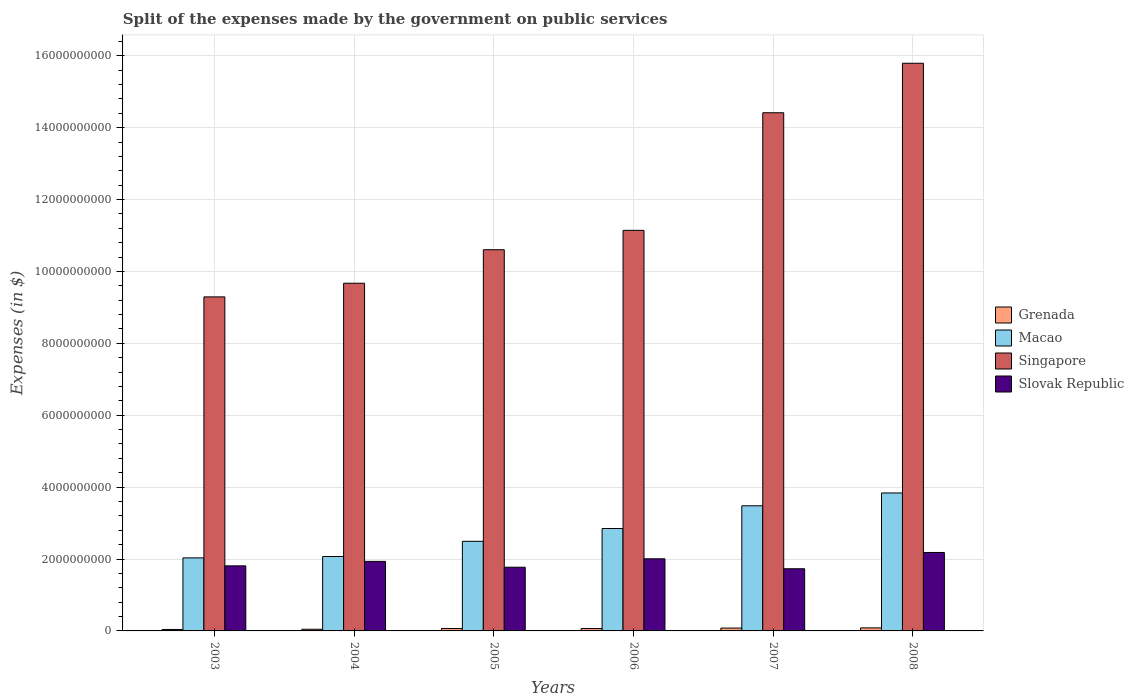How many bars are there on the 4th tick from the right?
Offer a terse response. 4. In how many cases, is the number of bars for a given year not equal to the number of legend labels?
Give a very brief answer. 0. What is the expenses made by the government on public services in Grenada in 2007?
Provide a succinct answer. 7.91e+07. Across all years, what is the maximum expenses made by the government on public services in Singapore?
Provide a short and direct response. 1.58e+1. Across all years, what is the minimum expenses made by the government on public services in Grenada?
Ensure brevity in your answer.  4.05e+07. What is the total expenses made by the government on public services in Slovak Republic in the graph?
Provide a succinct answer. 1.14e+1. What is the difference between the expenses made by the government on public services in Grenada in 2003 and that in 2005?
Provide a succinct answer. -2.74e+07. What is the difference between the expenses made by the government on public services in Grenada in 2006 and the expenses made by the government on public services in Macao in 2004?
Your answer should be compact. -2.00e+09. What is the average expenses made by the government on public services in Slovak Republic per year?
Give a very brief answer. 1.91e+09. In the year 2003, what is the difference between the expenses made by the government on public services in Singapore and expenses made by the government on public services in Grenada?
Provide a short and direct response. 9.25e+09. In how many years, is the expenses made by the government on public services in Slovak Republic greater than 2800000000 $?
Provide a succinct answer. 0. What is the ratio of the expenses made by the government on public services in Slovak Republic in 2005 to that in 2006?
Give a very brief answer. 0.88. Is the difference between the expenses made by the government on public services in Singapore in 2005 and 2007 greater than the difference between the expenses made by the government on public services in Grenada in 2005 and 2007?
Ensure brevity in your answer.  No. What is the difference between the highest and the second highest expenses made by the government on public services in Singapore?
Keep it short and to the point. 1.38e+09. What is the difference between the highest and the lowest expenses made by the government on public services in Grenada?
Give a very brief answer. 4.42e+07. In how many years, is the expenses made by the government on public services in Slovak Republic greater than the average expenses made by the government on public services in Slovak Republic taken over all years?
Your answer should be very brief. 3. Is the sum of the expenses made by the government on public services in Grenada in 2004 and 2007 greater than the maximum expenses made by the government on public services in Slovak Republic across all years?
Keep it short and to the point. No. Is it the case that in every year, the sum of the expenses made by the government on public services in Slovak Republic and expenses made by the government on public services in Macao is greater than the sum of expenses made by the government on public services in Singapore and expenses made by the government on public services in Grenada?
Give a very brief answer. Yes. What does the 3rd bar from the left in 2003 represents?
Provide a short and direct response. Singapore. What does the 4th bar from the right in 2007 represents?
Provide a succinct answer. Grenada. Is it the case that in every year, the sum of the expenses made by the government on public services in Singapore and expenses made by the government on public services in Grenada is greater than the expenses made by the government on public services in Slovak Republic?
Offer a terse response. Yes. How many years are there in the graph?
Your answer should be compact. 6. Does the graph contain grids?
Provide a short and direct response. Yes. How many legend labels are there?
Your answer should be very brief. 4. What is the title of the graph?
Provide a short and direct response. Split of the expenses made by the government on public services. What is the label or title of the Y-axis?
Your response must be concise. Expenses (in $). What is the Expenses (in $) in Grenada in 2003?
Provide a succinct answer. 4.05e+07. What is the Expenses (in $) of Macao in 2003?
Ensure brevity in your answer.  2.03e+09. What is the Expenses (in $) of Singapore in 2003?
Provide a succinct answer. 9.29e+09. What is the Expenses (in $) in Slovak Republic in 2003?
Make the answer very short. 1.81e+09. What is the Expenses (in $) in Grenada in 2004?
Make the answer very short. 4.61e+07. What is the Expenses (in $) in Macao in 2004?
Ensure brevity in your answer.  2.07e+09. What is the Expenses (in $) in Singapore in 2004?
Provide a succinct answer. 9.67e+09. What is the Expenses (in $) in Slovak Republic in 2004?
Make the answer very short. 1.93e+09. What is the Expenses (in $) in Grenada in 2005?
Provide a short and direct response. 6.79e+07. What is the Expenses (in $) of Macao in 2005?
Your response must be concise. 2.49e+09. What is the Expenses (in $) of Singapore in 2005?
Your response must be concise. 1.06e+1. What is the Expenses (in $) in Slovak Republic in 2005?
Offer a terse response. 1.77e+09. What is the Expenses (in $) of Grenada in 2006?
Ensure brevity in your answer.  6.61e+07. What is the Expenses (in $) in Macao in 2006?
Provide a short and direct response. 2.85e+09. What is the Expenses (in $) in Singapore in 2006?
Ensure brevity in your answer.  1.11e+1. What is the Expenses (in $) in Slovak Republic in 2006?
Your answer should be very brief. 2.01e+09. What is the Expenses (in $) in Grenada in 2007?
Offer a terse response. 7.91e+07. What is the Expenses (in $) in Macao in 2007?
Provide a succinct answer. 3.48e+09. What is the Expenses (in $) in Singapore in 2007?
Ensure brevity in your answer.  1.44e+1. What is the Expenses (in $) of Slovak Republic in 2007?
Provide a short and direct response. 1.73e+09. What is the Expenses (in $) of Grenada in 2008?
Your response must be concise. 8.47e+07. What is the Expenses (in $) in Macao in 2008?
Your answer should be compact. 3.84e+09. What is the Expenses (in $) in Singapore in 2008?
Give a very brief answer. 1.58e+1. What is the Expenses (in $) in Slovak Republic in 2008?
Provide a succinct answer. 2.18e+09. Across all years, what is the maximum Expenses (in $) of Grenada?
Offer a terse response. 8.47e+07. Across all years, what is the maximum Expenses (in $) of Macao?
Offer a terse response. 3.84e+09. Across all years, what is the maximum Expenses (in $) in Singapore?
Provide a succinct answer. 1.58e+1. Across all years, what is the maximum Expenses (in $) of Slovak Republic?
Offer a terse response. 2.18e+09. Across all years, what is the minimum Expenses (in $) in Grenada?
Keep it short and to the point. 4.05e+07. Across all years, what is the minimum Expenses (in $) in Macao?
Offer a very short reply. 2.03e+09. Across all years, what is the minimum Expenses (in $) in Singapore?
Your answer should be compact. 9.29e+09. Across all years, what is the minimum Expenses (in $) of Slovak Republic?
Ensure brevity in your answer.  1.73e+09. What is the total Expenses (in $) of Grenada in the graph?
Give a very brief answer. 3.84e+08. What is the total Expenses (in $) of Macao in the graph?
Give a very brief answer. 1.68e+1. What is the total Expenses (in $) of Singapore in the graph?
Ensure brevity in your answer.  7.09e+1. What is the total Expenses (in $) of Slovak Republic in the graph?
Your answer should be compact. 1.14e+1. What is the difference between the Expenses (in $) in Grenada in 2003 and that in 2004?
Give a very brief answer. -5.60e+06. What is the difference between the Expenses (in $) of Macao in 2003 and that in 2004?
Your answer should be compact. -3.86e+07. What is the difference between the Expenses (in $) of Singapore in 2003 and that in 2004?
Make the answer very short. -3.80e+08. What is the difference between the Expenses (in $) of Slovak Republic in 2003 and that in 2004?
Ensure brevity in your answer.  -1.24e+08. What is the difference between the Expenses (in $) in Grenada in 2003 and that in 2005?
Your answer should be compact. -2.74e+07. What is the difference between the Expenses (in $) of Macao in 2003 and that in 2005?
Provide a succinct answer. -4.61e+08. What is the difference between the Expenses (in $) in Singapore in 2003 and that in 2005?
Keep it short and to the point. -1.31e+09. What is the difference between the Expenses (in $) in Slovak Republic in 2003 and that in 2005?
Your answer should be compact. 3.79e+07. What is the difference between the Expenses (in $) of Grenada in 2003 and that in 2006?
Ensure brevity in your answer.  -2.56e+07. What is the difference between the Expenses (in $) of Macao in 2003 and that in 2006?
Make the answer very short. -8.17e+08. What is the difference between the Expenses (in $) of Singapore in 2003 and that in 2006?
Provide a succinct answer. -1.85e+09. What is the difference between the Expenses (in $) of Slovak Republic in 2003 and that in 2006?
Provide a succinct answer. -1.96e+08. What is the difference between the Expenses (in $) of Grenada in 2003 and that in 2007?
Offer a terse response. -3.86e+07. What is the difference between the Expenses (in $) in Macao in 2003 and that in 2007?
Make the answer very short. -1.45e+09. What is the difference between the Expenses (in $) of Singapore in 2003 and that in 2007?
Give a very brief answer. -5.12e+09. What is the difference between the Expenses (in $) in Slovak Republic in 2003 and that in 2007?
Provide a short and direct response. 8.10e+07. What is the difference between the Expenses (in $) in Grenada in 2003 and that in 2008?
Keep it short and to the point. -4.42e+07. What is the difference between the Expenses (in $) in Macao in 2003 and that in 2008?
Ensure brevity in your answer.  -1.81e+09. What is the difference between the Expenses (in $) of Singapore in 2003 and that in 2008?
Provide a short and direct response. -6.50e+09. What is the difference between the Expenses (in $) in Slovak Republic in 2003 and that in 2008?
Give a very brief answer. -3.72e+08. What is the difference between the Expenses (in $) of Grenada in 2004 and that in 2005?
Give a very brief answer. -2.18e+07. What is the difference between the Expenses (in $) of Macao in 2004 and that in 2005?
Make the answer very short. -4.22e+08. What is the difference between the Expenses (in $) of Singapore in 2004 and that in 2005?
Make the answer very short. -9.32e+08. What is the difference between the Expenses (in $) of Slovak Republic in 2004 and that in 2005?
Make the answer very short. 1.62e+08. What is the difference between the Expenses (in $) in Grenada in 2004 and that in 2006?
Offer a terse response. -2.00e+07. What is the difference between the Expenses (in $) in Macao in 2004 and that in 2006?
Provide a short and direct response. -7.78e+08. What is the difference between the Expenses (in $) in Singapore in 2004 and that in 2006?
Your response must be concise. -1.47e+09. What is the difference between the Expenses (in $) of Slovak Republic in 2004 and that in 2006?
Ensure brevity in your answer.  -7.14e+07. What is the difference between the Expenses (in $) in Grenada in 2004 and that in 2007?
Offer a terse response. -3.30e+07. What is the difference between the Expenses (in $) in Macao in 2004 and that in 2007?
Provide a succinct answer. -1.41e+09. What is the difference between the Expenses (in $) of Singapore in 2004 and that in 2007?
Your response must be concise. -4.74e+09. What is the difference between the Expenses (in $) of Slovak Republic in 2004 and that in 2007?
Ensure brevity in your answer.  2.05e+08. What is the difference between the Expenses (in $) in Grenada in 2004 and that in 2008?
Offer a terse response. -3.86e+07. What is the difference between the Expenses (in $) in Macao in 2004 and that in 2008?
Give a very brief answer. -1.77e+09. What is the difference between the Expenses (in $) in Singapore in 2004 and that in 2008?
Offer a very short reply. -6.12e+09. What is the difference between the Expenses (in $) of Slovak Republic in 2004 and that in 2008?
Ensure brevity in your answer.  -2.48e+08. What is the difference between the Expenses (in $) in Grenada in 2005 and that in 2006?
Your response must be concise. 1.80e+06. What is the difference between the Expenses (in $) in Macao in 2005 and that in 2006?
Your response must be concise. -3.56e+08. What is the difference between the Expenses (in $) of Singapore in 2005 and that in 2006?
Keep it short and to the point. -5.39e+08. What is the difference between the Expenses (in $) of Slovak Republic in 2005 and that in 2006?
Keep it short and to the point. -2.34e+08. What is the difference between the Expenses (in $) in Grenada in 2005 and that in 2007?
Give a very brief answer. -1.12e+07. What is the difference between the Expenses (in $) of Macao in 2005 and that in 2007?
Offer a very short reply. -9.88e+08. What is the difference between the Expenses (in $) in Singapore in 2005 and that in 2007?
Give a very brief answer. -3.81e+09. What is the difference between the Expenses (in $) in Slovak Republic in 2005 and that in 2007?
Your answer should be compact. 4.31e+07. What is the difference between the Expenses (in $) of Grenada in 2005 and that in 2008?
Your answer should be compact. -1.68e+07. What is the difference between the Expenses (in $) of Macao in 2005 and that in 2008?
Offer a very short reply. -1.34e+09. What is the difference between the Expenses (in $) in Singapore in 2005 and that in 2008?
Provide a succinct answer. -5.19e+09. What is the difference between the Expenses (in $) of Slovak Republic in 2005 and that in 2008?
Your answer should be very brief. -4.10e+08. What is the difference between the Expenses (in $) of Grenada in 2006 and that in 2007?
Provide a short and direct response. -1.30e+07. What is the difference between the Expenses (in $) of Macao in 2006 and that in 2007?
Offer a very short reply. -6.32e+08. What is the difference between the Expenses (in $) of Singapore in 2006 and that in 2007?
Make the answer very short. -3.27e+09. What is the difference between the Expenses (in $) in Slovak Republic in 2006 and that in 2007?
Ensure brevity in your answer.  2.77e+08. What is the difference between the Expenses (in $) of Grenada in 2006 and that in 2008?
Offer a terse response. -1.86e+07. What is the difference between the Expenses (in $) of Macao in 2006 and that in 2008?
Make the answer very short. -9.89e+08. What is the difference between the Expenses (in $) of Singapore in 2006 and that in 2008?
Offer a terse response. -4.65e+09. What is the difference between the Expenses (in $) in Slovak Republic in 2006 and that in 2008?
Offer a terse response. -1.76e+08. What is the difference between the Expenses (in $) of Grenada in 2007 and that in 2008?
Ensure brevity in your answer.  -5.60e+06. What is the difference between the Expenses (in $) of Macao in 2007 and that in 2008?
Offer a terse response. -3.57e+08. What is the difference between the Expenses (in $) in Singapore in 2007 and that in 2008?
Offer a very short reply. -1.38e+09. What is the difference between the Expenses (in $) in Slovak Republic in 2007 and that in 2008?
Make the answer very short. -4.53e+08. What is the difference between the Expenses (in $) in Grenada in 2003 and the Expenses (in $) in Macao in 2004?
Give a very brief answer. -2.03e+09. What is the difference between the Expenses (in $) in Grenada in 2003 and the Expenses (in $) in Singapore in 2004?
Your response must be concise. -9.63e+09. What is the difference between the Expenses (in $) in Grenada in 2003 and the Expenses (in $) in Slovak Republic in 2004?
Ensure brevity in your answer.  -1.89e+09. What is the difference between the Expenses (in $) in Macao in 2003 and the Expenses (in $) in Singapore in 2004?
Keep it short and to the point. -7.64e+09. What is the difference between the Expenses (in $) of Macao in 2003 and the Expenses (in $) of Slovak Republic in 2004?
Give a very brief answer. 9.74e+07. What is the difference between the Expenses (in $) in Singapore in 2003 and the Expenses (in $) in Slovak Republic in 2004?
Ensure brevity in your answer.  7.36e+09. What is the difference between the Expenses (in $) in Grenada in 2003 and the Expenses (in $) in Macao in 2005?
Provide a succinct answer. -2.45e+09. What is the difference between the Expenses (in $) of Grenada in 2003 and the Expenses (in $) of Singapore in 2005?
Offer a terse response. -1.06e+1. What is the difference between the Expenses (in $) in Grenada in 2003 and the Expenses (in $) in Slovak Republic in 2005?
Make the answer very short. -1.73e+09. What is the difference between the Expenses (in $) in Macao in 2003 and the Expenses (in $) in Singapore in 2005?
Provide a short and direct response. -8.57e+09. What is the difference between the Expenses (in $) of Macao in 2003 and the Expenses (in $) of Slovak Republic in 2005?
Give a very brief answer. 2.60e+08. What is the difference between the Expenses (in $) of Singapore in 2003 and the Expenses (in $) of Slovak Republic in 2005?
Offer a terse response. 7.52e+09. What is the difference between the Expenses (in $) of Grenada in 2003 and the Expenses (in $) of Macao in 2006?
Your answer should be very brief. -2.81e+09. What is the difference between the Expenses (in $) in Grenada in 2003 and the Expenses (in $) in Singapore in 2006?
Your answer should be very brief. -1.11e+1. What is the difference between the Expenses (in $) in Grenada in 2003 and the Expenses (in $) in Slovak Republic in 2006?
Give a very brief answer. -1.97e+09. What is the difference between the Expenses (in $) in Macao in 2003 and the Expenses (in $) in Singapore in 2006?
Give a very brief answer. -9.11e+09. What is the difference between the Expenses (in $) in Macao in 2003 and the Expenses (in $) in Slovak Republic in 2006?
Ensure brevity in your answer.  2.60e+07. What is the difference between the Expenses (in $) in Singapore in 2003 and the Expenses (in $) in Slovak Republic in 2006?
Ensure brevity in your answer.  7.29e+09. What is the difference between the Expenses (in $) of Grenada in 2003 and the Expenses (in $) of Macao in 2007?
Offer a terse response. -3.44e+09. What is the difference between the Expenses (in $) in Grenada in 2003 and the Expenses (in $) in Singapore in 2007?
Ensure brevity in your answer.  -1.44e+1. What is the difference between the Expenses (in $) of Grenada in 2003 and the Expenses (in $) of Slovak Republic in 2007?
Provide a succinct answer. -1.69e+09. What is the difference between the Expenses (in $) of Macao in 2003 and the Expenses (in $) of Singapore in 2007?
Keep it short and to the point. -1.24e+1. What is the difference between the Expenses (in $) in Macao in 2003 and the Expenses (in $) in Slovak Republic in 2007?
Offer a very short reply. 3.03e+08. What is the difference between the Expenses (in $) in Singapore in 2003 and the Expenses (in $) in Slovak Republic in 2007?
Make the answer very short. 7.56e+09. What is the difference between the Expenses (in $) of Grenada in 2003 and the Expenses (in $) of Macao in 2008?
Make the answer very short. -3.80e+09. What is the difference between the Expenses (in $) in Grenada in 2003 and the Expenses (in $) in Singapore in 2008?
Provide a succinct answer. -1.58e+1. What is the difference between the Expenses (in $) of Grenada in 2003 and the Expenses (in $) of Slovak Republic in 2008?
Give a very brief answer. -2.14e+09. What is the difference between the Expenses (in $) in Macao in 2003 and the Expenses (in $) in Singapore in 2008?
Give a very brief answer. -1.38e+1. What is the difference between the Expenses (in $) in Macao in 2003 and the Expenses (in $) in Slovak Republic in 2008?
Make the answer very short. -1.50e+08. What is the difference between the Expenses (in $) of Singapore in 2003 and the Expenses (in $) of Slovak Republic in 2008?
Make the answer very short. 7.11e+09. What is the difference between the Expenses (in $) of Grenada in 2004 and the Expenses (in $) of Macao in 2005?
Make the answer very short. -2.45e+09. What is the difference between the Expenses (in $) of Grenada in 2004 and the Expenses (in $) of Singapore in 2005?
Offer a very short reply. -1.06e+1. What is the difference between the Expenses (in $) in Grenada in 2004 and the Expenses (in $) in Slovak Republic in 2005?
Provide a short and direct response. -1.73e+09. What is the difference between the Expenses (in $) of Macao in 2004 and the Expenses (in $) of Singapore in 2005?
Make the answer very short. -8.53e+09. What is the difference between the Expenses (in $) in Macao in 2004 and the Expenses (in $) in Slovak Republic in 2005?
Offer a terse response. 2.98e+08. What is the difference between the Expenses (in $) of Singapore in 2004 and the Expenses (in $) of Slovak Republic in 2005?
Your answer should be very brief. 7.90e+09. What is the difference between the Expenses (in $) of Grenada in 2004 and the Expenses (in $) of Macao in 2006?
Offer a terse response. -2.80e+09. What is the difference between the Expenses (in $) in Grenada in 2004 and the Expenses (in $) in Singapore in 2006?
Offer a terse response. -1.11e+1. What is the difference between the Expenses (in $) of Grenada in 2004 and the Expenses (in $) of Slovak Republic in 2006?
Your response must be concise. -1.96e+09. What is the difference between the Expenses (in $) of Macao in 2004 and the Expenses (in $) of Singapore in 2006?
Your response must be concise. -9.07e+09. What is the difference between the Expenses (in $) of Macao in 2004 and the Expenses (in $) of Slovak Republic in 2006?
Give a very brief answer. 6.46e+07. What is the difference between the Expenses (in $) in Singapore in 2004 and the Expenses (in $) in Slovak Republic in 2006?
Keep it short and to the point. 7.67e+09. What is the difference between the Expenses (in $) in Grenada in 2004 and the Expenses (in $) in Macao in 2007?
Ensure brevity in your answer.  -3.43e+09. What is the difference between the Expenses (in $) in Grenada in 2004 and the Expenses (in $) in Singapore in 2007?
Offer a very short reply. -1.44e+1. What is the difference between the Expenses (in $) in Grenada in 2004 and the Expenses (in $) in Slovak Republic in 2007?
Your answer should be compact. -1.68e+09. What is the difference between the Expenses (in $) in Macao in 2004 and the Expenses (in $) in Singapore in 2007?
Keep it short and to the point. -1.23e+1. What is the difference between the Expenses (in $) of Macao in 2004 and the Expenses (in $) of Slovak Republic in 2007?
Offer a very short reply. 3.41e+08. What is the difference between the Expenses (in $) of Singapore in 2004 and the Expenses (in $) of Slovak Republic in 2007?
Offer a terse response. 7.94e+09. What is the difference between the Expenses (in $) in Grenada in 2004 and the Expenses (in $) in Macao in 2008?
Ensure brevity in your answer.  -3.79e+09. What is the difference between the Expenses (in $) of Grenada in 2004 and the Expenses (in $) of Singapore in 2008?
Provide a short and direct response. -1.57e+1. What is the difference between the Expenses (in $) of Grenada in 2004 and the Expenses (in $) of Slovak Republic in 2008?
Offer a terse response. -2.14e+09. What is the difference between the Expenses (in $) of Macao in 2004 and the Expenses (in $) of Singapore in 2008?
Ensure brevity in your answer.  -1.37e+1. What is the difference between the Expenses (in $) in Macao in 2004 and the Expenses (in $) in Slovak Republic in 2008?
Provide a short and direct response. -1.12e+08. What is the difference between the Expenses (in $) in Singapore in 2004 and the Expenses (in $) in Slovak Republic in 2008?
Provide a succinct answer. 7.49e+09. What is the difference between the Expenses (in $) of Grenada in 2005 and the Expenses (in $) of Macao in 2006?
Your answer should be very brief. -2.78e+09. What is the difference between the Expenses (in $) of Grenada in 2005 and the Expenses (in $) of Singapore in 2006?
Your answer should be very brief. -1.11e+1. What is the difference between the Expenses (in $) of Grenada in 2005 and the Expenses (in $) of Slovak Republic in 2006?
Offer a terse response. -1.94e+09. What is the difference between the Expenses (in $) in Macao in 2005 and the Expenses (in $) in Singapore in 2006?
Your answer should be compact. -8.65e+09. What is the difference between the Expenses (in $) in Macao in 2005 and the Expenses (in $) in Slovak Republic in 2006?
Offer a very short reply. 4.87e+08. What is the difference between the Expenses (in $) in Singapore in 2005 and the Expenses (in $) in Slovak Republic in 2006?
Keep it short and to the point. 8.60e+09. What is the difference between the Expenses (in $) in Grenada in 2005 and the Expenses (in $) in Macao in 2007?
Make the answer very short. -3.41e+09. What is the difference between the Expenses (in $) of Grenada in 2005 and the Expenses (in $) of Singapore in 2007?
Provide a short and direct response. -1.43e+1. What is the difference between the Expenses (in $) in Grenada in 2005 and the Expenses (in $) in Slovak Republic in 2007?
Offer a very short reply. -1.66e+09. What is the difference between the Expenses (in $) of Macao in 2005 and the Expenses (in $) of Singapore in 2007?
Your response must be concise. -1.19e+1. What is the difference between the Expenses (in $) in Macao in 2005 and the Expenses (in $) in Slovak Republic in 2007?
Your answer should be compact. 7.64e+08. What is the difference between the Expenses (in $) of Singapore in 2005 and the Expenses (in $) of Slovak Republic in 2007?
Keep it short and to the point. 8.87e+09. What is the difference between the Expenses (in $) in Grenada in 2005 and the Expenses (in $) in Macao in 2008?
Your answer should be very brief. -3.77e+09. What is the difference between the Expenses (in $) in Grenada in 2005 and the Expenses (in $) in Singapore in 2008?
Your answer should be compact. -1.57e+1. What is the difference between the Expenses (in $) in Grenada in 2005 and the Expenses (in $) in Slovak Republic in 2008?
Ensure brevity in your answer.  -2.11e+09. What is the difference between the Expenses (in $) of Macao in 2005 and the Expenses (in $) of Singapore in 2008?
Provide a succinct answer. -1.33e+1. What is the difference between the Expenses (in $) in Macao in 2005 and the Expenses (in $) in Slovak Republic in 2008?
Offer a terse response. 3.11e+08. What is the difference between the Expenses (in $) of Singapore in 2005 and the Expenses (in $) of Slovak Republic in 2008?
Offer a very short reply. 8.42e+09. What is the difference between the Expenses (in $) in Grenada in 2006 and the Expenses (in $) in Macao in 2007?
Provide a succinct answer. -3.41e+09. What is the difference between the Expenses (in $) of Grenada in 2006 and the Expenses (in $) of Singapore in 2007?
Offer a terse response. -1.43e+1. What is the difference between the Expenses (in $) of Grenada in 2006 and the Expenses (in $) of Slovak Republic in 2007?
Your answer should be very brief. -1.66e+09. What is the difference between the Expenses (in $) in Macao in 2006 and the Expenses (in $) in Singapore in 2007?
Make the answer very short. -1.16e+1. What is the difference between the Expenses (in $) in Macao in 2006 and the Expenses (in $) in Slovak Republic in 2007?
Provide a short and direct response. 1.12e+09. What is the difference between the Expenses (in $) in Singapore in 2006 and the Expenses (in $) in Slovak Republic in 2007?
Keep it short and to the point. 9.41e+09. What is the difference between the Expenses (in $) of Grenada in 2006 and the Expenses (in $) of Macao in 2008?
Make the answer very short. -3.77e+09. What is the difference between the Expenses (in $) of Grenada in 2006 and the Expenses (in $) of Singapore in 2008?
Your response must be concise. -1.57e+1. What is the difference between the Expenses (in $) in Grenada in 2006 and the Expenses (in $) in Slovak Republic in 2008?
Your response must be concise. -2.12e+09. What is the difference between the Expenses (in $) of Macao in 2006 and the Expenses (in $) of Singapore in 2008?
Provide a succinct answer. -1.29e+1. What is the difference between the Expenses (in $) of Macao in 2006 and the Expenses (in $) of Slovak Republic in 2008?
Provide a succinct answer. 6.67e+08. What is the difference between the Expenses (in $) of Singapore in 2006 and the Expenses (in $) of Slovak Republic in 2008?
Give a very brief answer. 8.96e+09. What is the difference between the Expenses (in $) of Grenada in 2007 and the Expenses (in $) of Macao in 2008?
Your response must be concise. -3.76e+09. What is the difference between the Expenses (in $) of Grenada in 2007 and the Expenses (in $) of Singapore in 2008?
Offer a terse response. -1.57e+1. What is the difference between the Expenses (in $) in Grenada in 2007 and the Expenses (in $) in Slovak Republic in 2008?
Make the answer very short. -2.10e+09. What is the difference between the Expenses (in $) of Macao in 2007 and the Expenses (in $) of Singapore in 2008?
Provide a short and direct response. -1.23e+1. What is the difference between the Expenses (in $) in Macao in 2007 and the Expenses (in $) in Slovak Republic in 2008?
Offer a terse response. 1.30e+09. What is the difference between the Expenses (in $) of Singapore in 2007 and the Expenses (in $) of Slovak Republic in 2008?
Your answer should be very brief. 1.22e+1. What is the average Expenses (in $) in Grenada per year?
Provide a short and direct response. 6.41e+07. What is the average Expenses (in $) in Macao per year?
Provide a short and direct response. 2.79e+09. What is the average Expenses (in $) in Singapore per year?
Ensure brevity in your answer.  1.18e+1. What is the average Expenses (in $) of Slovak Republic per year?
Offer a very short reply. 1.91e+09. In the year 2003, what is the difference between the Expenses (in $) in Grenada and Expenses (in $) in Macao?
Offer a very short reply. -1.99e+09. In the year 2003, what is the difference between the Expenses (in $) of Grenada and Expenses (in $) of Singapore?
Provide a succinct answer. -9.25e+09. In the year 2003, what is the difference between the Expenses (in $) of Grenada and Expenses (in $) of Slovak Republic?
Give a very brief answer. -1.77e+09. In the year 2003, what is the difference between the Expenses (in $) of Macao and Expenses (in $) of Singapore?
Your answer should be compact. -7.26e+09. In the year 2003, what is the difference between the Expenses (in $) of Macao and Expenses (in $) of Slovak Republic?
Keep it short and to the point. 2.22e+08. In the year 2003, what is the difference between the Expenses (in $) in Singapore and Expenses (in $) in Slovak Republic?
Offer a very short reply. 7.48e+09. In the year 2004, what is the difference between the Expenses (in $) of Grenada and Expenses (in $) of Macao?
Your answer should be compact. -2.02e+09. In the year 2004, what is the difference between the Expenses (in $) of Grenada and Expenses (in $) of Singapore?
Offer a very short reply. -9.63e+09. In the year 2004, what is the difference between the Expenses (in $) of Grenada and Expenses (in $) of Slovak Republic?
Provide a succinct answer. -1.89e+09. In the year 2004, what is the difference between the Expenses (in $) in Macao and Expenses (in $) in Singapore?
Offer a terse response. -7.60e+09. In the year 2004, what is the difference between the Expenses (in $) of Macao and Expenses (in $) of Slovak Republic?
Your answer should be compact. 1.36e+08. In the year 2004, what is the difference between the Expenses (in $) in Singapore and Expenses (in $) in Slovak Republic?
Your answer should be very brief. 7.74e+09. In the year 2005, what is the difference between the Expenses (in $) in Grenada and Expenses (in $) in Macao?
Provide a succinct answer. -2.43e+09. In the year 2005, what is the difference between the Expenses (in $) of Grenada and Expenses (in $) of Singapore?
Keep it short and to the point. -1.05e+1. In the year 2005, what is the difference between the Expenses (in $) in Grenada and Expenses (in $) in Slovak Republic?
Provide a succinct answer. -1.70e+09. In the year 2005, what is the difference between the Expenses (in $) in Macao and Expenses (in $) in Singapore?
Offer a terse response. -8.11e+09. In the year 2005, what is the difference between the Expenses (in $) in Macao and Expenses (in $) in Slovak Republic?
Keep it short and to the point. 7.21e+08. In the year 2005, what is the difference between the Expenses (in $) of Singapore and Expenses (in $) of Slovak Republic?
Make the answer very short. 8.83e+09. In the year 2006, what is the difference between the Expenses (in $) in Grenada and Expenses (in $) in Macao?
Provide a succinct answer. -2.78e+09. In the year 2006, what is the difference between the Expenses (in $) in Grenada and Expenses (in $) in Singapore?
Offer a terse response. -1.11e+1. In the year 2006, what is the difference between the Expenses (in $) of Grenada and Expenses (in $) of Slovak Republic?
Provide a succinct answer. -1.94e+09. In the year 2006, what is the difference between the Expenses (in $) in Macao and Expenses (in $) in Singapore?
Your response must be concise. -8.29e+09. In the year 2006, what is the difference between the Expenses (in $) of Macao and Expenses (in $) of Slovak Republic?
Provide a short and direct response. 8.43e+08. In the year 2006, what is the difference between the Expenses (in $) in Singapore and Expenses (in $) in Slovak Republic?
Give a very brief answer. 9.14e+09. In the year 2007, what is the difference between the Expenses (in $) of Grenada and Expenses (in $) of Macao?
Your response must be concise. -3.40e+09. In the year 2007, what is the difference between the Expenses (in $) of Grenada and Expenses (in $) of Singapore?
Your answer should be very brief. -1.43e+1. In the year 2007, what is the difference between the Expenses (in $) in Grenada and Expenses (in $) in Slovak Republic?
Keep it short and to the point. -1.65e+09. In the year 2007, what is the difference between the Expenses (in $) in Macao and Expenses (in $) in Singapore?
Offer a terse response. -1.09e+1. In the year 2007, what is the difference between the Expenses (in $) in Macao and Expenses (in $) in Slovak Republic?
Your response must be concise. 1.75e+09. In the year 2007, what is the difference between the Expenses (in $) of Singapore and Expenses (in $) of Slovak Republic?
Your answer should be compact. 1.27e+1. In the year 2008, what is the difference between the Expenses (in $) in Grenada and Expenses (in $) in Macao?
Keep it short and to the point. -3.75e+09. In the year 2008, what is the difference between the Expenses (in $) of Grenada and Expenses (in $) of Singapore?
Make the answer very short. -1.57e+1. In the year 2008, what is the difference between the Expenses (in $) in Grenada and Expenses (in $) in Slovak Republic?
Your answer should be compact. -2.10e+09. In the year 2008, what is the difference between the Expenses (in $) in Macao and Expenses (in $) in Singapore?
Your response must be concise. -1.20e+1. In the year 2008, what is the difference between the Expenses (in $) of Macao and Expenses (in $) of Slovak Republic?
Provide a short and direct response. 1.66e+09. In the year 2008, what is the difference between the Expenses (in $) in Singapore and Expenses (in $) in Slovak Republic?
Your answer should be compact. 1.36e+1. What is the ratio of the Expenses (in $) in Grenada in 2003 to that in 2004?
Give a very brief answer. 0.88. What is the ratio of the Expenses (in $) in Macao in 2003 to that in 2004?
Your answer should be compact. 0.98. What is the ratio of the Expenses (in $) in Singapore in 2003 to that in 2004?
Provide a succinct answer. 0.96. What is the ratio of the Expenses (in $) in Slovak Republic in 2003 to that in 2004?
Give a very brief answer. 0.94. What is the ratio of the Expenses (in $) of Grenada in 2003 to that in 2005?
Give a very brief answer. 0.6. What is the ratio of the Expenses (in $) in Macao in 2003 to that in 2005?
Provide a short and direct response. 0.82. What is the ratio of the Expenses (in $) in Singapore in 2003 to that in 2005?
Provide a succinct answer. 0.88. What is the ratio of the Expenses (in $) of Slovak Republic in 2003 to that in 2005?
Provide a short and direct response. 1.02. What is the ratio of the Expenses (in $) in Grenada in 2003 to that in 2006?
Keep it short and to the point. 0.61. What is the ratio of the Expenses (in $) of Macao in 2003 to that in 2006?
Your answer should be very brief. 0.71. What is the ratio of the Expenses (in $) of Singapore in 2003 to that in 2006?
Keep it short and to the point. 0.83. What is the ratio of the Expenses (in $) of Slovak Republic in 2003 to that in 2006?
Offer a terse response. 0.9. What is the ratio of the Expenses (in $) of Grenada in 2003 to that in 2007?
Your response must be concise. 0.51. What is the ratio of the Expenses (in $) of Macao in 2003 to that in 2007?
Your answer should be compact. 0.58. What is the ratio of the Expenses (in $) in Singapore in 2003 to that in 2007?
Make the answer very short. 0.64. What is the ratio of the Expenses (in $) in Slovak Republic in 2003 to that in 2007?
Keep it short and to the point. 1.05. What is the ratio of the Expenses (in $) of Grenada in 2003 to that in 2008?
Offer a terse response. 0.48. What is the ratio of the Expenses (in $) in Macao in 2003 to that in 2008?
Make the answer very short. 0.53. What is the ratio of the Expenses (in $) of Singapore in 2003 to that in 2008?
Offer a terse response. 0.59. What is the ratio of the Expenses (in $) of Slovak Republic in 2003 to that in 2008?
Offer a very short reply. 0.83. What is the ratio of the Expenses (in $) in Grenada in 2004 to that in 2005?
Your answer should be compact. 0.68. What is the ratio of the Expenses (in $) in Macao in 2004 to that in 2005?
Provide a short and direct response. 0.83. What is the ratio of the Expenses (in $) in Singapore in 2004 to that in 2005?
Provide a short and direct response. 0.91. What is the ratio of the Expenses (in $) of Slovak Republic in 2004 to that in 2005?
Make the answer very short. 1.09. What is the ratio of the Expenses (in $) of Grenada in 2004 to that in 2006?
Keep it short and to the point. 0.7. What is the ratio of the Expenses (in $) of Macao in 2004 to that in 2006?
Offer a very short reply. 0.73. What is the ratio of the Expenses (in $) of Singapore in 2004 to that in 2006?
Ensure brevity in your answer.  0.87. What is the ratio of the Expenses (in $) of Slovak Republic in 2004 to that in 2006?
Make the answer very short. 0.96. What is the ratio of the Expenses (in $) in Grenada in 2004 to that in 2007?
Ensure brevity in your answer.  0.58. What is the ratio of the Expenses (in $) of Macao in 2004 to that in 2007?
Make the answer very short. 0.59. What is the ratio of the Expenses (in $) in Singapore in 2004 to that in 2007?
Provide a short and direct response. 0.67. What is the ratio of the Expenses (in $) of Slovak Republic in 2004 to that in 2007?
Provide a succinct answer. 1.12. What is the ratio of the Expenses (in $) in Grenada in 2004 to that in 2008?
Make the answer very short. 0.54. What is the ratio of the Expenses (in $) of Macao in 2004 to that in 2008?
Your answer should be compact. 0.54. What is the ratio of the Expenses (in $) of Singapore in 2004 to that in 2008?
Provide a short and direct response. 0.61. What is the ratio of the Expenses (in $) of Slovak Republic in 2004 to that in 2008?
Your answer should be very brief. 0.89. What is the ratio of the Expenses (in $) of Grenada in 2005 to that in 2006?
Provide a short and direct response. 1.03. What is the ratio of the Expenses (in $) in Singapore in 2005 to that in 2006?
Offer a terse response. 0.95. What is the ratio of the Expenses (in $) of Slovak Republic in 2005 to that in 2006?
Keep it short and to the point. 0.88. What is the ratio of the Expenses (in $) in Grenada in 2005 to that in 2007?
Your answer should be compact. 0.86. What is the ratio of the Expenses (in $) of Macao in 2005 to that in 2007?
Your response must be concise. 0.72. What is the ratio of the Expenses (in $) of Singapore in 2005 to that in 2007?
Offer a very short reply. 0.74. What is the ratio of the Expenses (in $) in Slovak Republic in 2005 to that in 2007?
Your response must be concise. 1.02. What is the ratio of the Expenses (in $) of Grenada in 2005 to that in 2008?
Provide a succinct answer. 0.8. What is the ratio of the Expenses (in $) of Macao in 2005 to that in 2008?
Ensure brevity in your answer.  0.65. What is the ratio of the Expenses (in $) of Singapore in 2005 to that in 2008?
Offer a terse response. 0.67. What is the ratio of the Expenses (in $) in Slovak Republic in 2005 to that in 2008?
Keep it short and to the point. 0.81. What is the ratio of the Expenses (in $) of Grenada in 2006 to that in 2007?
Provide a succinct answer. 0.84. What is the ratio of the Expenses (in $) in Macao in 2006 to that in 2007?
Offer a terse response. 0.82. What is the ratio of the Expenses (in $) of Singapore in 2006 to that in 2007?
Your response must be concise. 0.77. What is the ratio of the Expenses (in $) of Slovak Republic in 2006 to that in 2007?
Keep it short and to the point. 1.16. What is the ratio of the Expenses (in $) of Grenada in 2006 to that in 2008?
Ensure brevity in your answer.  0.78. What is the ratio of the Expenses (in $) of Macao in 2006 to that in 2008?
Give a very brief answer. 0.74. What is the ratio of the Expenses (in $) of Singapore in 2006 to that in 2008?
Offer a very short reply. 0.71. What is the ratio of the Expenses (in $) of Slovak Republic in 2006 to that in 2008?
Your answer should be very brief. 0.92. What is the ratio of the Expenses (in $) of Grenada in 2007 to that in 2008?
Offer a very short reply. 0.93. What is the ratio of the Expenses (in $) in Macao in 2007 to that in 2008?
Your response must be concise. 0.91. What is the ratio of the Expenses (in $) in Singapore in 2007 to that in 2008?
Your answer should be very brief. 0.91. What is the ratio of the Expenses (in $) in Slovak Republic in 2007 to that in 2008?
Offer a very short reply. 0.79. What is the difference between the highest and the second highest Expenses (in $) in Grenada?
Provide a short and direct response. 5.60e+06. What is the difference between the highest and the second highest Expenses (in $) in Macao?
Offer a terse response. 3.57e+08. What is the difference between the highest and the second highest Expenses (in $) in Singapore?
Ensure brevity in your answer.  1.38e+09. What is the difference between the highest and the second highest Expenses (in $) of Slovak Republic?
Your answer should be very brief. 1.76e+08. What is the difference between the highest and the lowest Expenses (in $) of Grenada?
Your answer should be compact. 4.42e+07. What is the difference between the highest and the lowest Expenses (in $) of Macao?
Your answer should be very brief. 1.81e+09. What is the difference between the highest and the lowest Expenses (in $) in Singapore?
Offer a very short reply. 6.50e+09. What is the difference between the highest and the lowest Expenses (in $) of Slovak Republic?
Make the answer very short. 4.53e+08. 